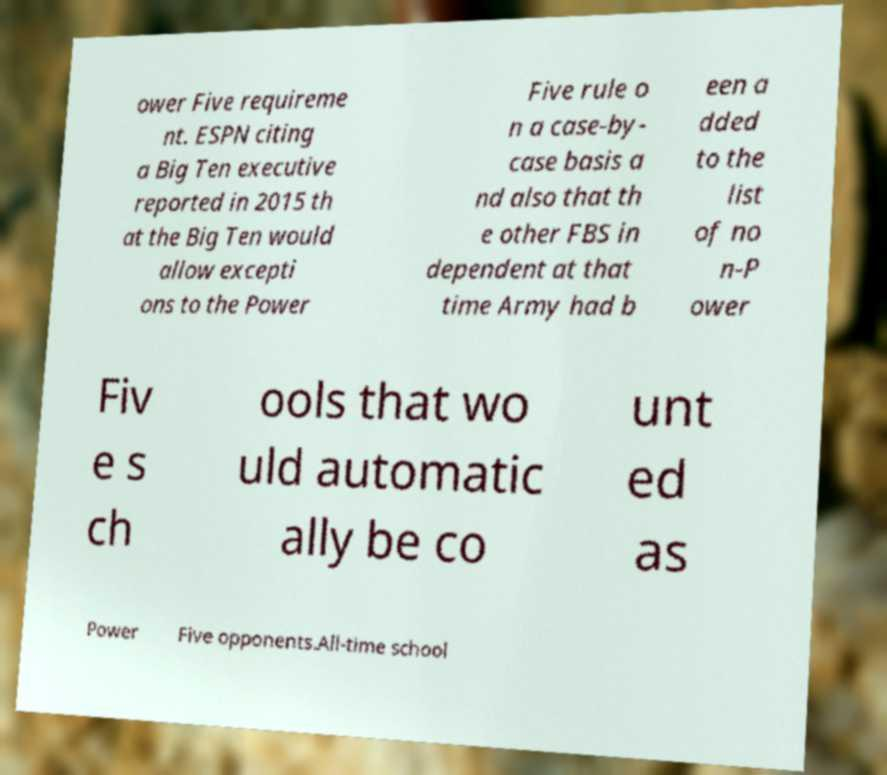I need the written content from this picture converted into text. Can you do that? ower Five requireme nt. ESPN citing a Big Ten executive reported in 2015 th at the Big Ten would allow excepti ons to the Power Five rule o n a case-by- case basis a nd also that th e other FBS in dependent at that time Army had b een a dded to the list of no n-P ower Fiv e s ch ools that wo uld automatic ally be co unt ed as Power Five opponents.All-time school 